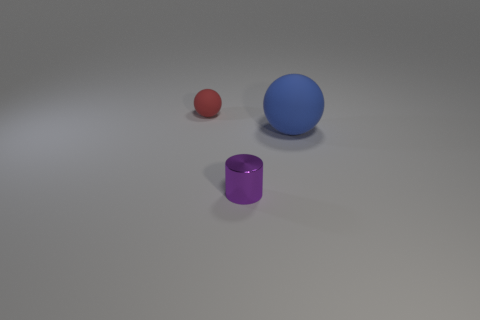What color is the tiny matte thing? The tiny matte object in the image appears to be a small, red sphere. Its size is considerably smaller when compared to the two larger objects: a blue sphere and a purple cylinder. 